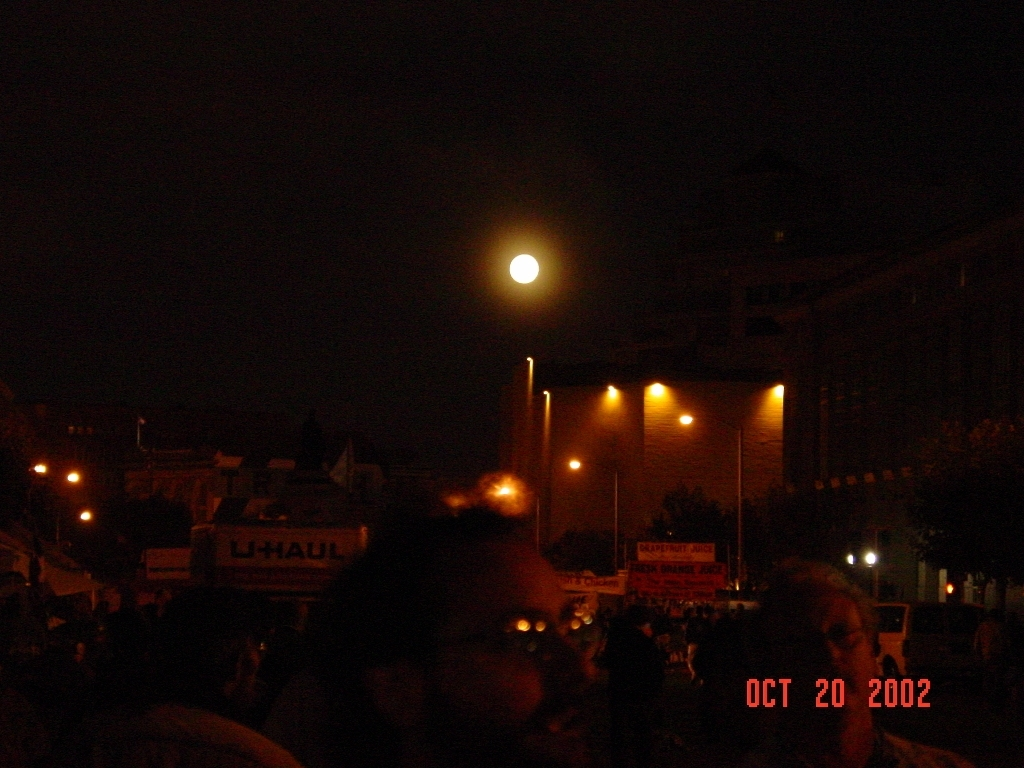What time of day does this photo seem to have been taken, and what hints at that? The photo appears to have been taken at night, as indicated by the darkness in the sky, artificial lighting illuminating the area, and the presence of what seems to be a moon or artificial light source that resembles the moon. 